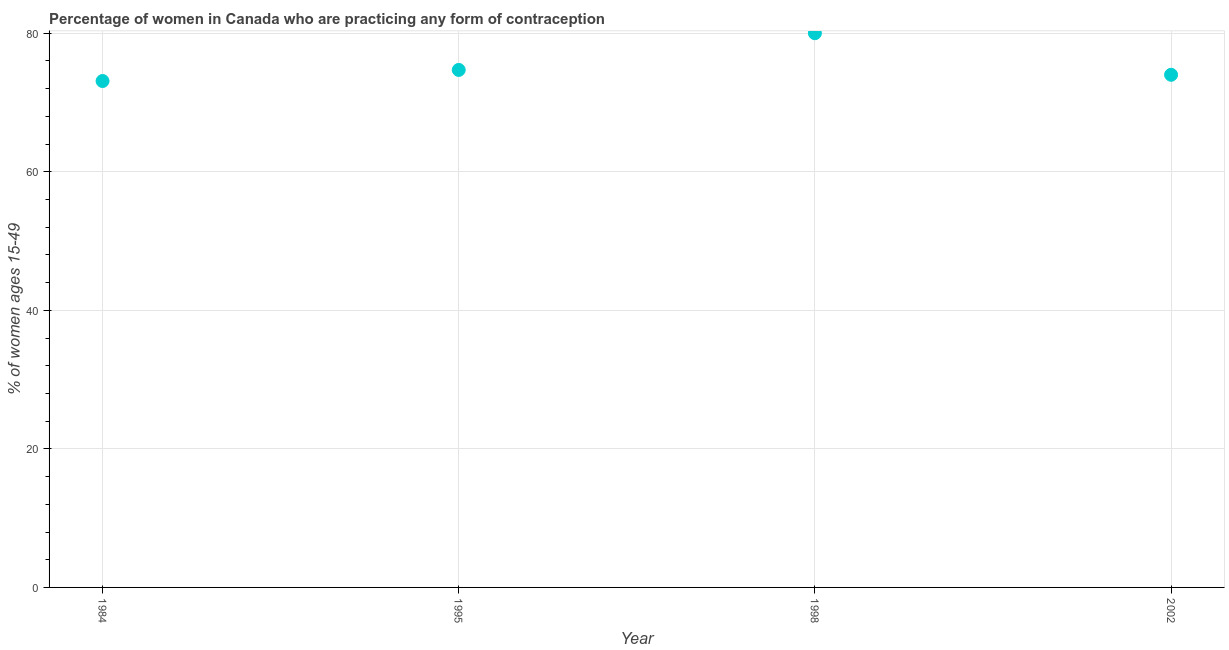What is the contraceptive prevalence in 1995?
Provide a short and direct response. 74.7. Across all years, what is the minimum contraceptive prevalence?
Give a very brief answer. 73.1. In which year was the contraceptive prevalence minimum?
Make the answer very short. 1984. What is the sum of the contraceptive prevalence?
Offer a terse response. 301.8. What is the difference between the contraceptive prevalence in 1995 and 1998?
Offer a terse response. -5.3. What is the average contraceptive prevalence per year?
Your answer should be compact. 75.45. What is the median contraceptive prevalence?
Your answer should be compact. 74.35. Do a majority of the years between 2002 and 1995 (inclusive) have contraceptive prevalence greater than 60 %?
Your answer should be very brief. No. What is the ratio of the contraceptive prevalence in 1984 to that in 2002?
Offer a very short reply. 0.99. Is the difference between the contraceptive prevalence in 1995 and 1998 greater than the difference between any two years?
Ensure brevity in your answer.  No. What is the difference between the highest and the second highest contraceptive prevalence?
Offer a very short reply. 5.3. Is the sum of the contraceptive prevalence in 1984 and 1998 greater than the maximum contraceptive prevalence across all years?
Provide a short and direct response. Yes. What is the difference between the highest and the lowest contraceptive prevalence?
Give a very brief answer. 6.9. What is the difference between two consecutive major ticks on the Y-axis?
Give a very brief answer. 20. What is the title of the graph?
Provide a short and direct response. Percentage of women in Canada who are practicing any form of contraception. What is the label or title of the Y-axis?
Offer a terse response. % of women ages 15-49. What is the % of women ages 15-49 in 1984?
Offer a very short reply. 73.1. What is the % of women ages 15-49 in 1995?
Provide a short and direct response. 74.7. What is the % of women ages 15-49 in 2002?
Your answer should be very brief. 74. What is the difference between the % of women ages 15-49 in 1984 and 1998?
Your response must be concise. -6.9. What is the difference between the % of women ages 15-49 in 1984 and 2002?
Your answer should be very brief. -0.9. What is the difference between the % of women ages 15-49 in 1995 and 1998?
Offer a terse response. -5.3. What is the difference between the % of women ages 15-49 in 1995 and 2002?
Give a very brief answer. 0.7. What is the ratio of the % of women ages 15-49 in 1984 to that in 1998?
Your response must be concise. 0.91. What is the ratio of the % of women ages 15-49 in 1984 to that in 2002?
Your response must be concise. 0.99. What is the ratio of the % of women ages 15-49 in 1995 to that in 1998?
Your response must be concise. 0.93. What is the ratio of the % of women ages 15-49 in 1995 to that in 2002?
Give a very brief answer. 1.01. What is the ratio of the % of women ages 15-49 in 1998 to that in 2002?
Give a very brief answer. 1.08. 